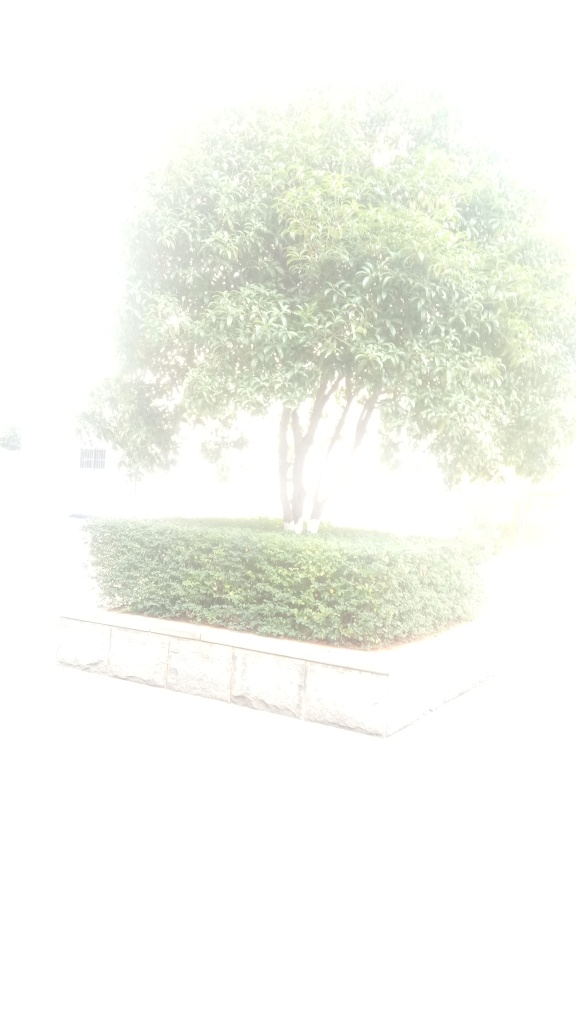Can you suggest any techniques to prevent overexposure in photos? To prevent overexposure, use a lower ISO setting, a faster shutter speed, or a smaller aperture. On sunny days, consider using a neutral density filter to reduce the amount of light that enters the lens. Also, be sure to check your camera’s histogram to ensure the lighting is well-balanced and adjust settings accordingly. 